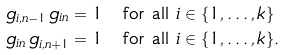Convert formula to latex. <formula><loc_0><loc_0><loc_500><loc_500>g _ { i , n - 1 } \, g _ { i n } & = 1 \quad \text {for all $i\in\{1,\dots,k\}$} \\ g _ { i n } \, g _ { i , n + 1 } & = 1 \quad \text {for all $i\in\{1,\dots,k\}$} .</formula> 